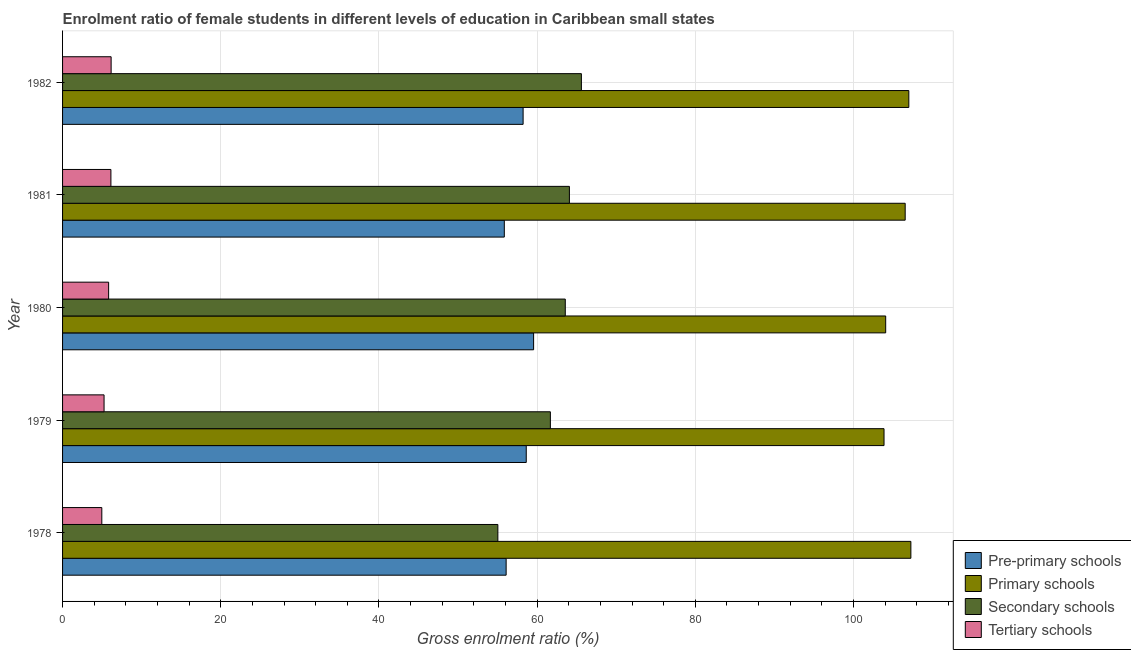How many different coloured bars are there?
Your response must be concise. 4. Are the number of bars on each tick of the Y-axis equal?
Your response must be concise. Yes. How many bars are there on the 5th tick from the top?
Offer a terse response. 4. How many bars are there on the 5th tick from the bottom?
Make the answer very short. 4. What is the label of the 5th group of bars from the top?
Offer a terse response. 1978. What is the gross enrolment ratio(male) in pre-primary schools in 1978?
Make the answer very short. 56.08. Across all years, what is the maximum gross enrolment ratio(male) in tertiary schools?
Make the answer very short. 6.14. Across all years, what is the minimum gross enrolment ratio(male) in pre-primary schools?
Offer a terse response. 55.86. In which year was the gross enrolment ratio(male) in primary schools maximum?
Your answer should be compact. 1978. In which year was the gross enrolment ratio(male) in primary schools minimum?
Offer a very short reply. 1979. What is the total gross enrolment ratio(male) in tertiary schools in the graph?
Your response must be concise. 28.28. What is the difference between the gross enrolment ratio(male) in pre-primary schools in 1981 and that in 1982?
Ensure brevity in your answer.  -2.38. What is the difference between the gross enrolment ratio(male) in pre-primary schools in 1981 and the gross enrolment ratio(male) in secondary schools in 1982?
Provide a short and direct response. -9.74. What is the average gross enrolment ratio(male) in secondary schools per year?
Your response must be concise. 61.99. In the year 1979, what is the difference between the gross enrolment ratio(male) in pre-primary schools and gross enrolment ratio(male) in secondary schools?
Provide a succinct answer. -3.05. In how many years, is the gross enrolment ratio(male) in secondary schools greater than 36 %?
Your response must be concise. 5. Is the gross enrolment ratio(male) in primary schools in 1978 less than that in 1982?
Offer a very short reply. No. Is the difference between the gross enrolment ratio(male) in pre-primary schools in 1979 and 1980 greater than the difference between the gross enrolment ratio(male) in primary schools in 1979 and 1980?
Make the answer very short. No. What is the difference between the highest and the second highest gross enrolment ratio(male) in pre-primary schools?
Your answer should be compact. 0.93. What is the difference between the highest and the lowest gross enrolment ratio(male) in tertiary schools?
Provide a short and direct response. 1.18. In how many years, is the gross enrolment ratio(male) in pre-primary schools greater than the average gross enrolment ratio(male) in pre-primary schools taken over all years?
Your response must be concise. 3. Is the sum of the gross enrolment ratio(male) in primary schools in 1978 and 1981 greater than the maximum gross enrolment ratio(male) in pre-primary schools across all years?
Keep it short and to the point. Yes. What does the 2nd bar from the top in 1982 represents?
Ensure brevity in your answer.  Secondary schools. What does the 4th bar from the bottom in 1979 represents?
Provide a succinct answer. Tertiary schools. How many years are there in the graph?
Your answer should be very brief. 5. Where does the legend appear in the graph?
Provide a succinct answer. Bottom right. How many legend labels are there?
Provide a succinct answer. 4. How are the legend labels stacked?
Provide a succinct answer. Vertical. What is the title of the graph?
Provide a succinct answer. Enrolment ratio of female students in different levels of education in Caribbean small states. What is the label or title of the X-axis?
Offer a terse response. Gross enrolment ratio (%). What is the label or title of the Y-axis?
Keep it short and to the point. Year. What is the Gross enrolment ratio (%) in Pre-primary schools in 1978?
Your response must be concise. 56.08. What is the Gross enrolment ratio (%) in Primary schools in 1978?
Provide a succinct answer. 107.26. What is the Gross enrolment ratio (%) of Secondary schools in 1978?
Offer a terse response. 55.04. What is the Gross enrolment ratio (%) of Tertiary schools in 1978?
Your response must be concise. 4.96. What is the Gross enrolment ratio (%) in Pre-primary schools in 1979?
Offer a terse response. 58.63. What is the Gross enrolment ratio (%) of Primary schools in 1979?
Offer a terse response. 103.87. What is the Gross enrolment ratio (%) in Secondary schools in 1979?
Provide a succinct answer. 61.68. What is the Gross enrolment ratio (%) of Tertiary schools in 1979?
Your answer should be compact. 5.25. What is the Gross enrolment ratio (%) of Pre-primary schools in 1980?
Make the answer very short. 59.56. What is the Gross enrolment ratio (%) of Primary schools in 1980?
Provide a short and direct response. 104.08. What is the Gross enrolment ratio (%) in Secondary schools in 1980?
Ensure brevity in your answer.  63.56. What is the Gross enrolment ratio (%) in Tertiary schools in 1980?
Offer a very short reply. 5.82. What is the Gross enrolment ratio (%) in Pre-primary schools in 1981?
Provide a succinct answer. 55.86. What is the Gross enrolment ratio (%) in Primary schools in 1981?
Offer a terse response. 106.54. What is the Gross enrolment ratio (%) of Secondary schools in 1981?
Provide a succinct answer. 64.09. What is the Gross enrolment ratio (%) of Tertiary schools in 1981?
Your answer should be compact. 6.11. What is the Gross enrolment ratio (%) in Pre-primary schools in 1982?
Offer a terse response. 58.23. What is the Gross enrolment ratio (%) of Primary schools in 1982?
Provide a short and direct response. 107. What is the Gross enrolment ratio (%) in Secondary schools in 1982?
Provide a succinct answer. 65.6. What is the Gross enrolment ratio (%) in Tertiary schools in 1982?
Provide a short and direct response. 6.14. Across all years, what is the maximum Gross enrolment ratio (%) in Pre-primary schools?
Ensure brevity in your answer.  59.56. Across all years, what is the maximum Gross enrolment ratio (%) in Primary schools?
Your response must be concise. 107.26. Across all years, what is the maximum Gross enrolment ratio (%) of Secondary schools?
Your response must be concise. 65.6. Across all years, what is the maximum Gross enrolment ratio (%) of Tertiary schools?
Provide a succinct answer. 6.14. Across all years, what is the minimum Gross enrolment ratio (%) in Pre-primary schools?
Your response must be concise. 55.86. Across all years, what is the minimum Gross enrolment ratio (%) in Primary schools?
Give a very brief answer. 103.87. Across all years, what is the minimum Gross enrolment ratio (%) in Secondary schools?
Give a very brief answer. 55.04. Across all years, what is the minimum Gross enrolment ratio (%) of Tertiary schools?
Provide a succinct answer. 4.96. What is the total Gross enrolment ratio (%) of Pre-primary schools in the graph?
Offer a very short reply. 288.36. What is the total Gross enrolment ratio (%) of Primary schools in the graph?
Your response must be concise. 528.74. What is the total Gross enrolment ratio (%) in Secondary schools in the graph?
Provide a short and direct response. 309.97. What is the total Gross enrolment ratio (%) of Tertiary schools in the graph?
Provide a short and direct response. 28.28. What is the difference between the Gross enrolment ratio (%) of Pre-primary schools in 1978 and that in 1979?
Your response must be concise. -2.54. What is the difference between the Gross enrolment ratio (%) in Primary schools in 1978 and that in 1979?
Your response must be concise. 3.39. What is the difference between the Gross enrolment ratio (%) of Secondary schools in 1978 and that in 1979?
Ensure brevity in your answer.  -6.64. What is the difference between the Gross enrolment ratio (%) in Tertiary schools in 1978 and that in 1979?
Make the answer very short. -0.28. What is the difference between the Gross enrolment ratio (%) in Pre-primary schools in 1978 and that in 1980?
Keep it short and to the point. -3.47. What is the difference between the Gross enrolment ratio (%) of Primary schools in 1978 and that in 1980?
Offer a very short reply. 3.19. What is the difference between the Gross enrolment ratio (%) of Secondary schools in 1978 and that in 1980?
Offer a very short reply. -8.53. What is the difference between the Gross enrolment ratio (%) in Tertiary schools in 1978 and that in 1980?
Keep it short and to the point. -0.86. What is the difference between the Gross enrolment ratio (%) in Pre-primary schools in 1978 and that in 1981?
Your answer should be compact. 0.23. What is the difference between the Gross enrolment ratio (%) of Primary schools in 1978 and that in 1981?
Ensure brevity in your answer.  0.72. What is the difference between the Gross enrolment ratio (%) of Secondary schools in 1978 and that in 1981?
Offer a very short reply. -9.05. What is the difference between the Gross enrolment ratio (%) in Tertiary schools in 1978 and that in 1981?
Offer a terse response. -1.15. What is the difference between the Gross enrolment ratio (%) of Pre-primary schools in 1978 and that in 1982?
Your answer should be compact. -2.15. What is the difference between the Gross enrolment ratio (%) of Primary schools in 1978 and that in 1982?
Give a very brief answer. 0.26. What is the difference between the Gross enrolment ratio (%) in Secondary schools in 1978 and that in 1982?
Make the answer very short. -10.56. What is the difference between the Gross enrolment ratio (%) in Tertiary schools in 1978 and that in 1982?
Offer a terse response. -1.18. What is the difference between the Gross enrolment ratio (%) of Pre-primary schools in 1979 and that in 1980?
Give a very brief answer. -0.93. What is the difference between the Gross enrolment ratio (%) of Primary schools in 1979 and that in 1980?
Make the answer very short. -0.21. What is the difference between the Gross enrolment ratio (%) in Secondary schools in 1979 and that in 1980?
Your response must be concise. -1.89. What is the difference between the Gross enrolment ratio (%) of Tertiary schools in 1979 and that in 1980?
Offer a very short reply. -0.58. What is the difference between the Gross enrolment ratio (%) of Pre-primary schools in 1979 and that in 1981?
Offer a very short reply. 2.77. What is the difference between the Gross enrolment ratio (%) in Primary schools in 1979 and that in 1981?
Your answer should be compact. -2.67. What is the difference between the Gross enrolment ratio (%) of Secondary schools in 1979 and that in 1981?
Your answer should be very brief. -2.41. What is the difference between the Gross enrolment ratio (%) in Tertiary schools in 1979 and that in 1981?
Keep it short and to the point. -0.86. What is the difference between the Gross enrolment ratio (%) of Pre-primary schools in 1979 and that in 1982?
Ensure brevity in your answer.  0.4. What is the difference between the Gross enrolment ratio (%) of Primary schools in 1979 and that in 1982?
Provide a succinct answer. -3.14. What is the difference between the Gross enrolment ratio (%) in Secondary schools in 1979 and that in 1982?
Give a very brief answer. -3.92. What is the difference between the Gross enrolment ratio (%) in Tertiary schools in 1979 and that in 1982?
Ensure brevity in your answer.  -0.89. What is the difference between the Gross enrolment ratio (%) in Pre-primary schools in 1980 and that in 1981?
Give a very brief answer. 3.7. What is the difference between the Gross enrolment ratio (%) of Primary schools in 1980 and that in 1981?
Offer a terse response. -2.47. What is the difference between the Gross enrolment ratio (%) of Secondary schools in 1980 and that in 1981?
Give a very brief answer. -0.52. What is the difference between the Gross enrolment ratio (%) of Tertiary schools in 1980 and that in 1981?
Ensure brevity in your answer.  -0.29. What is the difference between the Gross enrolment ratio (%) in Pre-primary schools in 1980 and that in 1982?
Offer a terse response. 1.33. What is the difference between the Gross enrolment ratio (%) in Primary schools in 1980 and that in 1982?
Provide a succinct answer. -2.93. What is the difference between the Gross enrolment ratio (%) in Secondary schools in 1980 and that in 1982?
Make the answer very short. -2.04. What is the difference between the Gross enrolment ratio (%) in Tertiary schools in 1980 and that in 1982?
Keep it short and to the point. -0.32. What is the difference between the Gross enrolment ratio (%) in Pre-primary schools in 1981 and that in 1982?
Make the answer very short. -2.38. What is the difference between the Gross enrolment ratio (%) in Primary schools in 1981 and that in 1982?
Provide a succinct answer. -0.46. What is the difference between the Gross enrolment ratio (%) in Secondary schools in 1981 and that in 1982?
Your answer should be very brief. -1.51. What is the difference between the Gross enrolment ratio (%) of Tertiary schools in 1981 and that in 1982?
Offer a very short reply. -0.03. What is the difference between the Gross enrolment ratio (%) in Pre-primary schools in 1978 and the Gross enrolment ratio (%) in Primary schools in 1979?
Offer a very short reply. -47.78. What is the difference between the Gross enrolment ratio (%) in Pre-primary schools in 1978 and the Gross enrolment ratio (%) in Secondary schools in 1979?
Your answer should be compact. -5.59. What is the difference between the Gross enrolment ratio (%) of Pre-primary schools in 1978 and the Gross enrolment ratio (%) of Tertiary schools in 1979?
Provide a short and direct response. 50.84. What is the difference between the Gross enrolment ratio (%) of Primary schools in 1978 and the Gross enrolment ratio (%) of Secondary schools in 1979?
Offer a terse response. 45.58. What is the difference between the Gross enrolment ratio (%) of Primary schools in 1978 and the Gross enrolment ratio (%) of Tertiary schools in 1979?
Your answer should be very brief. 102.01. What is the difference between the Gross enrolment ratio (%) of Secondary schools in 1978 and the Gross enrolment ratio (%) of Tertiary schools in 1979?
Offer a terse response. 49.79. What is the difference between the Gross enrolment ratio (%) of Pre-primary schools in 1978 and the Gross enrolment ratio (%) of Primary schools in 1980?
Offer a very short reply. -47.99. What is the difference between the Gross enrolment ratio (%) of Pre-primary schools in 1978 and the Gross enrolment ratio (%) of Secondary schools in 1980?
Give a very brief answer. -7.48. What is the difference between the Gross enrolment ratio (%) in Pre-primary schools in 1978 and the Gross enrolment ratio (%) in Tertiary schools in 1980?
Your response must be concise. 50.26. What is the difference between the Gross enrolment ratio (%) in Primary schools in 1978 and the Gross enrolment ratio (%) in Secondary schools in 1980?
Ensure brevity in your answer.  43.7. What is the difference between the Gross enrolment ratio (%) of Primary schools in 1978 and the Gross enrolment ratio (%) of Tertiary schools in 1980?
Your response must be concise. 101.44. What is the difference between the Gross enrolment ratio (%) in Secondary schools in 1978 and the Gross enrolment ratio (%) in Tertiary schools in 1980?
Provide a short and direct response. 49.22. What is the difference between the Gross enrolment ratio (%) in Pre-primary schools in 1978 and the Gross enrolment ratio (%) in Primary schools in 1981?
Make the answer very short. -50.46. What is the difference between the Gross enrolment ratio (%) in Pre-primary schools in 1978 and the Gross enrolment ratio (%) in Secondary schools in 1981?
Provide a succinct answer. -8. What is the difference between the Gross enrolment ratio (%) in Pre-primary schools in 1978 and the Gross enrolment ratio (%) in Tertiary schools in 1981?
Your response must be concise. 49.97. What is the difference between the Gross enrolment ratio (%) of Primary schools in 1978 and the Gross enrolment ratio (%) of Secondary schools in 1981?
Your answer should be very brief. 43.17. What is the difference between the Gross enrolment ratio (%) in Primary schools in 1978 and the Gross enrolment ratio (%) in Tertiary schools in 1981?
Offer a very short reply. 101.15. What is the difference between the Gross enrolment ratio (%) of Secondary schools in 1978 and the Gross enrolment ratio (%) of Tertiary schools in 1981?
Keep it short and to the point. 48.93. What is the difference between the Gross enrolment ratio (%) of Pre-primary schools in 1978 and the Gross enrolment ratio (%) of Primary schools in 1982?
Offer a terse response. -50.92. What is the difference between the Gross enrolment ratio (%) in Pre-primary schools in 1978 and the Gross enrolment ratio (%) in Secondary schools in 1982?
Offer a very short reply. -9.52. What is the difference between the Gross enrolment ratio (%) of Pre-primary schools in 1978 and the Gross enrolment ratio (%) of Tertiary schools in 1982?
Make the answer very short. 49.95. What is the difference between the Gross enrolment ratio (%) in Primary schools in 1978 and the Gross enrolment ratio (%) in Secondary schools in 1982?
Your answer should be very brief. 41.66. What is the difference between the Gross enrolment ratio (%) of Primary schools in 1978 and the Gross enrolment ratio (%) of Tertiary schools in 1982?
Offer a terse response. 101.12. What is the difference between the Gross enrolment ratio (%) in Secondary schools in 1978 and the Gross enrolment ratio (%) in Tertiary schools in 1982?
Your answer should be compact. 48.9. What is the difference between the Gross enrolment ratio (%) in Pre-primary schools in 1979 and the Gross enrolment ratio (%) in Primary schools in 1980?
Provide a short and direct response. -45.45. What is the difference between the Gross enrolment ratio (%) of Pre-primary schools in 1979 and the Gross enrolment ratio (%) of Secondary schools in 1980?
Ensure brevity in your answer.  -4.94. What is the difference between the Gross enrolment ratio (%) of Pre-primary schools in 1979 and the Gross enrolment ratio (%) of Tertiary schools in 1980?
Make the answer very short. 52.8. What is the difference between the Gross enrolment ratio (%) of Primary schools in 1979 and the Gross enrolment ratio (%) of Secondary schools in 1980?
Make the answer very short. 40.3. What is the difference between the Gross enrolment ratio (%) of Primary schools in 1979 and the Gross enrolment ratio (%) of Tertiary schools in 1980?
Keep it short and to the point. 98.04. What is the difference between the Gross enrolment ratio (%) of Secondary schools in 1979 and the Gross enrolment ratio (%) of Tertiary schools in 1980?
Your answer should be very brief. 55.85. What is the difference between the Gross enrolment ratio (%) of Pre-primary schools in 1979 and the Gross enrolment ratio (%) of Primary schools in 1981?
Offer a terse response. -47.91. What is the difference between the Gross enrolment ratio (%) in Pre-primary schools in 1979 and the Gross enrolment ratio (%) in Secondary schools in 1981?
Offer a very short reply. -5.46. What is the difference between the Gross enrolment ratio (%) of Pre-primary schools in 1979 and the Gross enrolment ratio (%) of Tertiary schools in 1981?
Your answer should be very brief. 52.52. What is the difference between the Gross enrolment ratio (%) of Primary schools in 1979 and the Gross enrolment ratio (%) of Secondary schools in 1981?
Give a very brief answer. 39.78. What is the difference between the Gross enrolment ratio (%) of Primary schools in 1979 and the Gross enrolment ratio (%) of Tertiary schools in 1981?
Provide a short and direct response. 97.75. What is the difference between the Gross enrolment ratio (%) of Secondary schools in 1979 and the Gross enrolment ratio (%) of Tertiary schools in 1981?
Keep it short and to the point. 55.57. What is the difference between the Gross enrolment ratio (%) in Pre-primary schools in 1979 and the Gross enrolment ratio (%) in Primary schools in 1982?
Make the answer very short. -48.37. What is the difference between the Gross enrolment ratio (%) in Pre-primary schools in 1979 and the Gross enrolment ratio (%) in Secondary schools in 1982?
Make the answer very short. -6.97. What is the difference between the Gross enrolment ratio (%) of Pre-primary schools in 1979 and the Gross enrolment ratio (%) of Tertiary schools in 1982?
Ensure brevity in your answer.  52.49. What is the difference between the Gross enrolment ratio (%) of Primary schools in 1979 and the Gross enrolment ratio (%) of Secondary schools in 1982?
Ensure brevity in your answer.  38.27. What is the difference between the Gross enrolment ratio (%) in Primary schools in 1979 and the Gross enrolment ratio (%) in Tertiary schools in 1982?
Your response must be concise. 97.73. What is the difference between the Gross enrolment ratio (%) of Secondary schools in 1979 and the Gross enrolment ratio (%) of Tertiary schools in 1982?
Provide a succinct answer. 55.54. What is the difference between the Gross enrolment ratio (%) of Pre-primary schools in 1980 and the Gross enrolment ratio (%) of Primary schools in 1981?
Your answer should be very brief. -46.98. What is the difference between the Gross enrolment ratio (%) in Pre-primary schools in 1980 and the Gross enrolment ratio (%) in Secondary schools in 1981?
Provide a succinct answer. -4.53. What is the difference between the Gross enrolment ratio (%) in Pre-primary schools in 1980 and the Gross enrolment ratio (%) in Tertiary schools in 1981?
Provide a succinct answer. 53.45. What is the difference between the Gross enrolment ratio (%) in Primary schools in 1980 and the Gross enrolment ratio (%) in Secondary schools in 1981?
Provide a short and direct response. 39.99. What is the difference between the Gross enrolment ratio (%) in Primary schools in 1980 and the Gross enrolment ratio (%) in Tertiary schools in 1981?
Provide a short and direct response. 97.96. What is the difference between the Gross enrolment ratio (%) in Secondary schools in 1980 and the Gross enrolment ratio (%) in Tertiary schools in 1981?
Offer a terse response. 57.45. What is the difference between the Gross enrolment ratio (%) of Pre-primary schools in 1980 and the Gross enrolment ratio (%) of Primary schools in 1982?
Provide a succinct answer. -47.44. What is the difference between the Gross enrolment ratio (%) in Pre-primary schools in 1980 and the Gross enrolment ratio (%) in Secondary schools in 1982?
Provide a succinct answer. -6.04. What is the difference between the Gross enrolment ratio (%) of Pre-primary schools in 1980 and the Gross enrolment ratio (%) of Tertiary schools in 1982?
Give a very brief answer. 53.42. What is the difference between the Gross enrolment ratio (%) in Primary schools in 1980 and the Gross enrolment ratio (%) in Secondary schools in 1982?
Your answer should be compact. 38.48. What is the difference between the Gross enrolment ratio (%) of Primary schools in 1980 and the Gross enrolment ratio (%) of Tertiary schools in 1982?
Make the answer very short. 97.94. What is the difference between the Gross enrolment ratio (%) in Secondary schools in 1980 and the Gross enrolment ratio (%) in Tertiary schools in 1982?
Provide a succinct answer. 57.42. What is the difference between the Gross enrolment ratio (%) of Pre-primary schools in 1981 and the Gross enrolment ratio (%) of Primary schools in 1982?
Make the answer very short. -51.15. What is the difference between the Gross enrolment ratio (%) of Pre-primary schools in 1981 and the Gross enrolment ratio (%) of Secondary schools in 1982?
Make the answer very short. -9.74. What is the difference between the Gross enrolment ratio (%) in Pre-primary schools in 1981 and the Gross enrolment ratio (%) in Tertiary schools in 1982?
Offer a very short reply. 49.72. What is the difference between the Gross enrolment ratio (%) in Primary schools in 1981 and the Gross enrolment ratio (%) in Secondary schools in 1982?
Your response must be concise. 40.94. What is the difference between the Gross enrolment ratio (%) of Primary schools in 1981 and the Gross enrolment ratio (%) of Tertiary schools in 1982?
Offer a terse response. 100.4. What is the difference between the Gross enrolment ratio (%) in Secondary schools in 1981 and the Gross enrolment ratio (%) in Tertiary schools in 1982?
Provide a succinct answer. 57.95. What is the average Gross enrolment ratio (%) of Pre-primary schools per year?
Your response must be concise. 57.67. What is the average Gross enrolment ratio (%) of Primary schools per year?
Your answer should be very brief. 105.75. What is the average Gross enrolment ratio (%) in Secondary schools per year?
Your response must be concise. 61.99. What is the average Gross enrolment ratio (%) in Tertiary schools per year?
Keep it short and to the point. 5.66. In the year 1978, what is the difference between the Gross enrolment ratio (%) of Pre-primary schools and Gross enrolment ratio (%) of Primary schools?
Your answer should be compact. -51.18. In the year 1978, what is the difference between the Gross enrolment ratio (%) in Pre-primary schools and Gross enrolment ratio (%) in Secondary schools?
Your answer should be compact. 1.05. In the year 1978, what is the difference between the Gross enrolment ratio (%) of Pre-primary schools and Gross enrolment ratio (%) of Tertiary schools?
Your response must be concise. 51.12. In the year 1978, what is the difference between the Gross enrolment ratio (%) in Primary schools and Gross enrolment ratio (%) in Secondary schools?
Offer a terse response. 52.22. In the year 1978, what is the difference between the Gross enrolment ratio (%) of Primary schools and Gross enrolment ratio (%) of Tertiary schools?
Your answer should be very brief. 102.3. In the year 1978, what is the difference between the Gross enrolment ratio (%) of Secondary schools and Gross enrolment ratio (%) of Tertiary schools?
Your answer should be very brief. 50.08. In the year 1979, what is the difference between the Gross enrolment ratio (%) of Pre-primary schools and Gross enrolment ratio (%) of Primary schools?
Give a very brief answer. -45.24. In the year 1979, what is the difference between the Gross enrolment ratio (%) in Pre-primary schools and Gross enrolment ratio (%) in Secondary schools?
Offer a very short reply. -3.05. In the year 1979, what is the difference between the Gross enrolment ratio (%) in Pre-primary schools and Gross enrolment ratio (%) in Tertiary schools?
Provide a short and direct response. 53.38. In the year 1979, what is the difference between the Gross enrolment ratio (%) of Primary schools and Gross enrolment ratio (%) of Secondary schools?
Ensure brevity in your answer.  42.19. In the year 1979, what is the difference between the Gross enrolment ratio (%) in Primary schools and Gross enrolment ratio (%) in Tertiary schools?
Offer a terse response. 98.62. In the year 1979, what is the difference between the Gross enrolment ratio (%) in Secondary schools and Gross enrolment ratio (%) in Tertiary schools?
Your response must be concise. 56.43. In the year 1980, what is the difference between the Gross enrolment ratio (%) of Pre-primary schools and Gross enrolment ratio (%) of Primary schools?
Provide a short and direct response. -44.52. In the year 1980, what is the difference between the Gross enrolment ratio (%) in Pre-primary schools and Gross enrolment ratio (%) in Secondary schools?
Your answer should be compact. -4. In the year 1980, what is the difference between the Gross enrolment ratio (%) of Pre-primary schools and Gross enrolment ratio (%) of Tertiary schools?
Ensure brevity in your answer.  53.74. In the year 1980, what is the difference between the Gross enrolment ratio (%) of Primary schools and Gross enrolment ratio (%) of Secondary schools?
Your answer should be compact. 40.51. In the year 1980, what is the difference between the Gross enrolment ratio (%) in Primary schools and Gross enrolment ratio (%) in Tertiary schools?
Offer a terse response. 98.25. In the year 1980, what is the difference between the Gross enrolment ratio (%) in Secondary schools and Gross enrolment ratio (%) in Tertiary schools?
Your answer should be compact. 57.74. In the year 1981, what is the difference between the Gross enrolment ratio (%) in Pre-primary schools and Gross enrolment ratio (%) in Primary schools?
Provide a short and direct response. -50.69. In the year 1981, what is the difference between the Gross enrolment ratio (%) in Pre-primary schools and Gross enrolment ratio (%) in Secondary schools?
Provide a short and direct response. -8.23. In the year 1981, what is the difference between the Gross enrolment ratio (%) in Pre-primary schools and Gross enrolment ratio (%) in Tertiary schools?
Offer a terse response. 49.74. In the year 1981, what is the difference between the Gross enrolment ratio (%) of Primary schools and Gross enrolment ratio (%) of Secondary schools?
Keep it short and to the point. 42.45. In the year 1981, what is the difference between the Gross enrolment ratio (%) of Primary schools and Gross enrolment ratio (%) of Tertiary schools?
Give a very brief answer. 100.43. In the year 1981, what is the difference between the Gross enrolment ratio (%) in Secondary schools and Gross enrolment ratio (%) in Tertiary schools?
Give a very brief answer. 57.97. In the year 1982, what is the difference between the Gross enrolment ratio (%) in Pre-primary schools and Gross enrolment ratio (%) in Primary schools?
Offer a terse response. -48.77. In the year 1982, what is the difference between the Gross enrolment ratio (%) in Pre-primary schools and Gross enrolment ratio (%) in Secondary schools?
Your response must be concise. -7.37. In the year 1982, what is the difference between the Gross enrolment ratio (%) in Pre-primary schools and Gross enrolment ratio (%) in Tertiary schools?
Your answer should be compact. 52.09. In the year 1982, what is the difference between the Gross enrolment ratio (%) in Primary schools and Gross enrolment ratio (%) in Secondary schools?
Provide a short and direct response. 41.4. In the year 1982, what is the difference between the Gross enrolment ratio (%) of Primary schools and Gross enrolment ratio (%) of Tertiary schools?
Offer a very short reply. 100.86. In the year 1982, what is the difference between the Gross enrolment ratio (%) of Secondary schools and Gross enrolment ratio (%) of Tertiary schools?
Ensure brevity in your answer.  59.46. What is the ratio of the Gross enrolment ratio (%) in Pre-primary schools in 1978 to that in 1979?
Offer a very short reply. 0.96. What is the ratio of the Gross enrolment ratio (%) in Primary schools in 1978 to that in 1979?
Provide a short and direct response. 1.03. What is the ratio of the Gross enrolment ratio (%) of Secondary schools in 1978 to that in 1979?
Provide a short and direct response. 0.89. What is the ratio of the Gross enrolment ratio (%) of Tertiary schools in 1978 to that in 1979?
Your response must be concise. 0.95. What is the ratio of the Gross enrolment ratio (%) in Pre-primary schools in 1978 to that in 1980?
Offer a terse response. 0.94. What is the ratio of the Gross enrolment ratio (%) of Primary schools in 1978 to that in 1980?
Provide a succinct answer. 1.03. What is the ratio of the Gross enrolment ratio (%) in Secondary schools in 1978 to that in 1980?
Keep it short and to the point. 0.87. What is the ratio of the Gross enrolment ratio (%) of Tertiary schools in 1978 to that in 1980?
Ensure brevity in your answer.  0.85. What is the ratio of the Gross enrolment ratio (%) of Pre-primary schools in 1978 to that in 1981?
Offer a terse response. 1. What is the ratio of the Gross enrolment ratio (%) in Primary schools in 1978 to that in 1981?
Keep it short and to the point. 1.01. What is the ratio of the Gross enrolment ratio (%) in Secondary schools in 1978 to that in 1981?
Make the answer very short. 0.86. What is the ratio of the Gross enrolment ratio (%) of Tertiary schools in 1978 to that in 1981?
Your answer should be compact. 0.81. What is the ratio of the Gross enrolment ratio (%) in Pre-primary schools in 1978 to that in 1982?
Your answer should be compact. 0.96. What is the ratio of the Gross enrolment ratio (%) in Primary schools in 1978 to that in 1982?
Provide a succinct answer. 1. What is the ratio of the Gross enrolment ratio (%) of Secondary schools in 1978 to that in 1982?
Provide a succinct answer. 0.84. What is the ratio of the Gross enrolment ratio (%) of Tertiary schools in 1978 to that in 1982?
Keep it short and to the point. 0.81. What is the ratio of the Gross enrolment ratio (%) of Pre-primary schools in 1979 to that in 1980?
Offer a very short reply. 0.98. What is the ratio of the Gross enrolment ratio (%) of Secondary schools in 1979 to that in 1980?
Ensure brevity in your answer.  0.97. What is the ratio of the Gross enrolment ratio (%) of Tertiary schools in 1979 to that in 1980?
Make the answer very short. 0.9. What is the ratio of the Gross enrolment ratio (%) in Pre-primary schools in 1979 to that in 1981?
Offer a very short reply. 1.05. What is the ratio of the Gross enrolment ratio (%) of Primary schools in 1979 to that in 1981?
Provide a succinct answer. 0.97. What is the ratio of the Gross enrolment ratio (%) in Secondary schools in 1979 to that in 1981?
Your answer should be compact. 0.96. What is the ratio of the Gross enrolment ratio (%) of Tertiary schools in 1979 to that in 1981?
Provide a succinct answer. 0.86. What is the ratio of the Gross enrolment ratio (%) in Pre-primary schools in 1979 to that in 1982?
Offer a terse response. 1.01. What is the ratio of the Gross enrolment ratio (%) in Primary schools in 1979 to that in 1982?
Provide a succinct answer. 0.97. What is the ratio of the Gross enrolment ratio (%) of Secondary schools in 1979 to that in 1982?
Give a very brief answer. 0.94. What is the ratio of the Gross enrolment ratio (%) of Tertiary schools in 1979 to that in 1982?
Provide a succinct answer. 0.85. What is the ratio of the Gross enrolment ratio (%) of Pre-primary schools in 1980 to that in 1981?
Give a very brief answer. 1.07. What is the ratio of the Gross enrolment ratio (%) in Primary schools in 1980 to that in 1981?
Ensure brevity in your answer.  0.98. What is the ratio of the Gross enrolment ratio (%) of Secondary schools in 1980 to that in 1981?
Keep it short and to the point. 0.99. What is the ratio of the Gross enrolment ratio (%) of Tertiary schools in 1980 to that in 1981?
Your answer should be compact. 0.95. What is the ratio of the Gross enrolment ratio (%) of Pre-primary schools in 1980 to that in 1982?
Offer a terse response. 1.02. What is the ratio of the Gross enrolment ratio (%) of Primary schools in 1980 to that in 1982?
Provide a succinct answer. 0.97. What is the ratio of the Gross enrolment ratio (%) of Secondary schools in 1980 to that in 1982?
Provide a short and direct response. 0.97. What is the ratio of the Gross enrolment ratio (%) of Tertiary schools in 1980 to that in 1982?
Make the answer very short. 0.95. What is the ratio of the Gross enrolment ratio (%) of Pre-primary schools in 1981 to that in 1982?
Offer a very short reply. 0.96. What is the ratio of the Gross enrolment ratio (%) of Primary schools in 1981 to that in 1982?
Your answer should be very brief. 1. What is the ratio of the Gross enrolment ratio (%) of Secondary schools in 1981 to that in 1982?
Offer a very short reply. 0.98. What is the difference between the highest and the second highest Gross enrolment ratio (%) of Pre-primary schools?
Ensure brevity in your answer.  0.93. What is the difference between the highest and the second highest Gross enrolment ratio (%) in Primary schools?
Your answer should be compact. 0.26. What is the difference between the highest and the second highest Gross enrolment ratio (%) in Secondary schools?
Ensure brevity in your answer.  1.51. What is the difference between the highest and the second highest Gross enrolment ratio (%) in Tertiary schools?
Ensure brevity in your answer.  0.03. What is the difference between the highest and the lowest Gross enrolment ratio (%) of Pre-primary schools?
Offer a very short reply. 3.7. What is the difference between the highest and the lowest Gross enrolment ratio (%) in Primary schools?
Keep it short and to the point. 3.39. What is the difference between the highest and the lowest Gross enrolment ratio (%) in Secondary schools?
Provide a succinct answer. 10.56. What is the difference between the highest and the lowest Gross enrolment ratio (%) in Tertiary schools?
Ensure brevity in your answer.  1.18. 